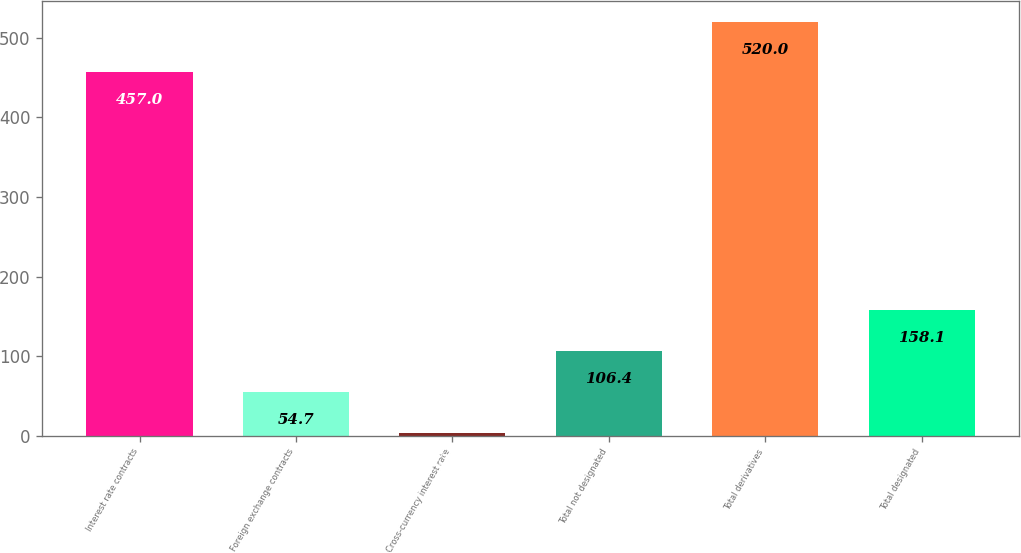Convert chart to OTSL. <chart><loc_0><loc_0><loc_500><loc_500><bar_chart><fcel>Interest rate contracts<fcel>Foreign exchange contracts<fcel>Cross-currency interest rate<fcel>Total not designated<fcel>Total derivatives<fcel>Total designated<nl><fcel>457<fcel>54.7<fcel>3<fcel>106.4<fcel>520<fcel>158.1<nl></chart> 